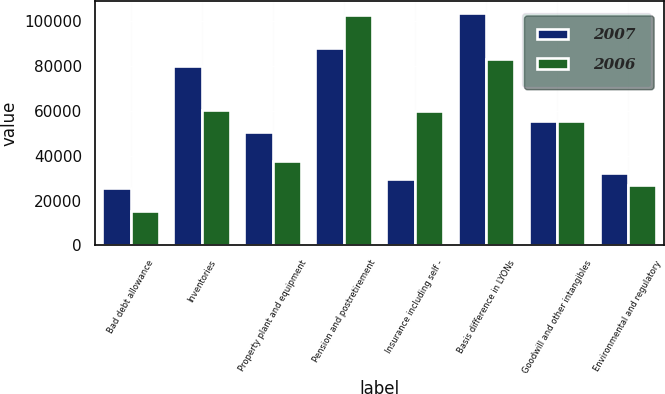Convert chart. <chart><loc_0><loc_0><loc_500><loc_500><stacked_bar_chart><ecel><fcel>Bad debt allowance<fcel>Inventories<fcel>Property plant and equipment<fcel>Pension and postretirement<fcel>Insurance including self -<fcel>Basis difference in LYONs<fcel>Goodwill and other intangibles<fcel>Environmental and regulatory<nl><fcel>2007<fcel>25812<fcel>80040<fcel>50486<fcel>87921<fcel>29636<fcel>103768<fcel>55306<fcel>32310<nl><fcel>2006<fcel>15377<fcel>60583<fcel>37595<fcel>102471<fcel>60126<fcel>82870<fcel>55306<fcel>26764<nl></chart> 